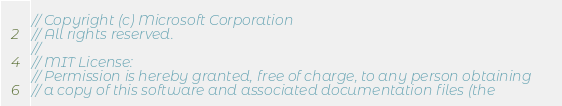Convert code to text. <code><loc_0><loc_0><loc_500><loc_500><_TypeScript_>// Copyright (c) Microsoft Corporation
// All rights reserved.
//
// MIT License:
// Permission is hereby granted, free of charge, to any person obtaining
// a copy of this software and associated documentation files (the</code> 